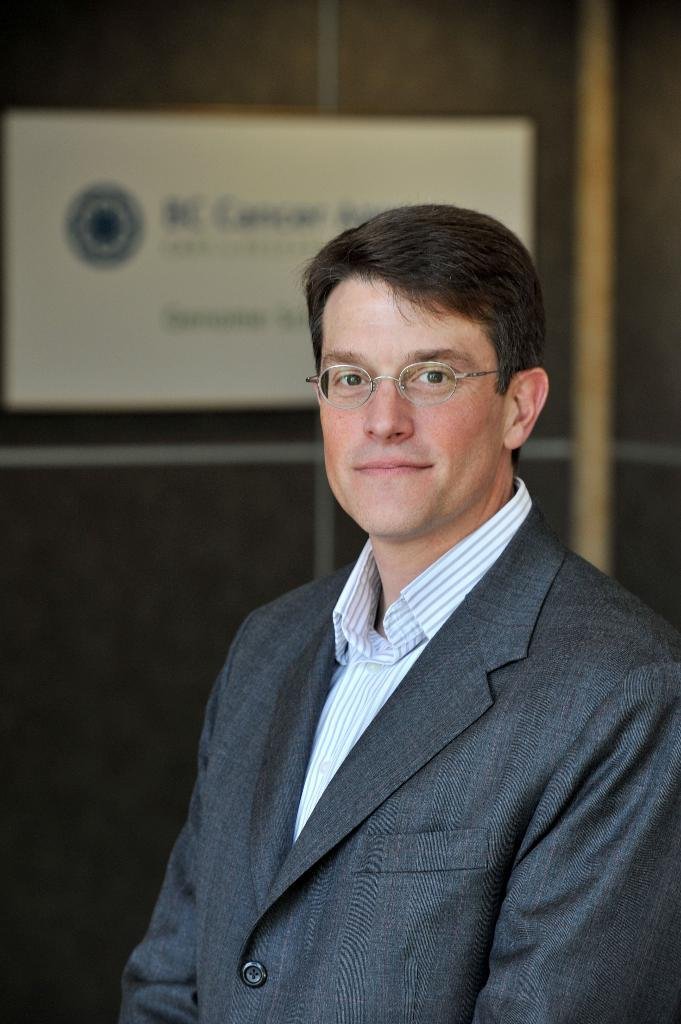Who is present in the image? There is a man in the image. What is the man wearing in the image? The man is wearing spectacles in the image. What is the man's posture in the image? The man is standing in the image. What can be seen in the background of the image? There is a wall in the background of the image. What is on the wall in the image? There is a poster on the wall in the image. What type of songs can be heard coming from the zoo in the image? There is no zoo present in the image, so it's not possible to determine what, if any, songs might be heard. 